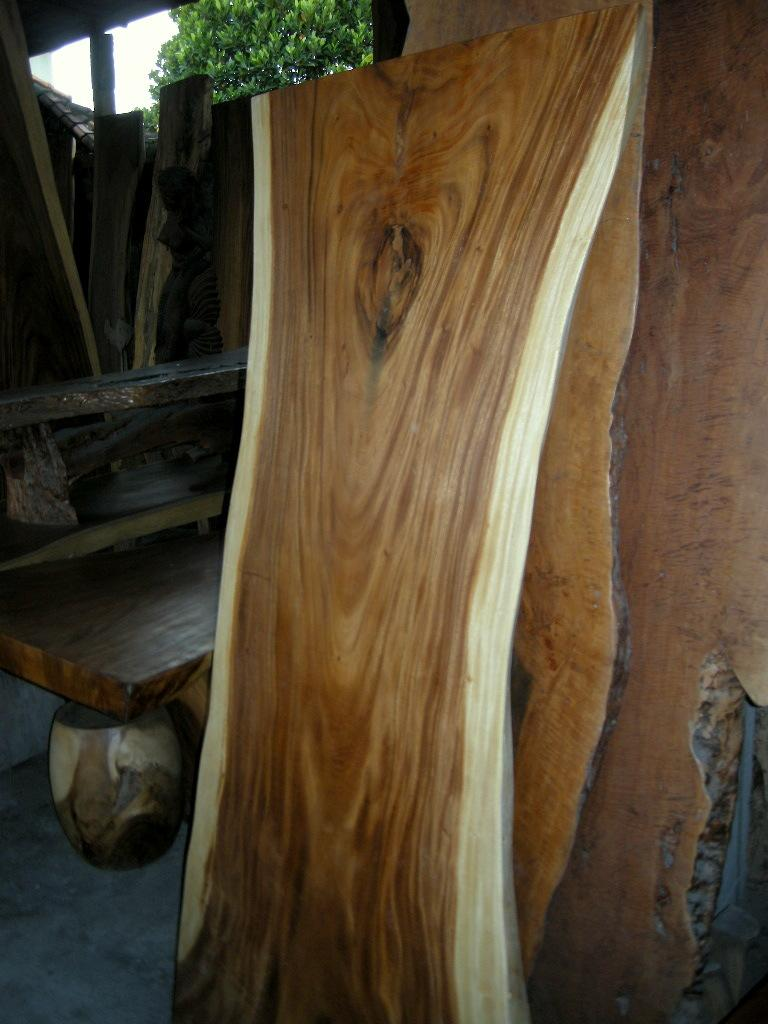What type of material is used to create the objects in the image? The objects in the image are made of wooden planks. How are the wooden planks arranged in the image? The wooden planks are placed together. What can be seen in the background of the image? There is a tree visible in the background of the image. What type of needle is being used for the activity in the image? There is no needle or activity present in the image; it features wooden planks placed together and a tree in the background. 